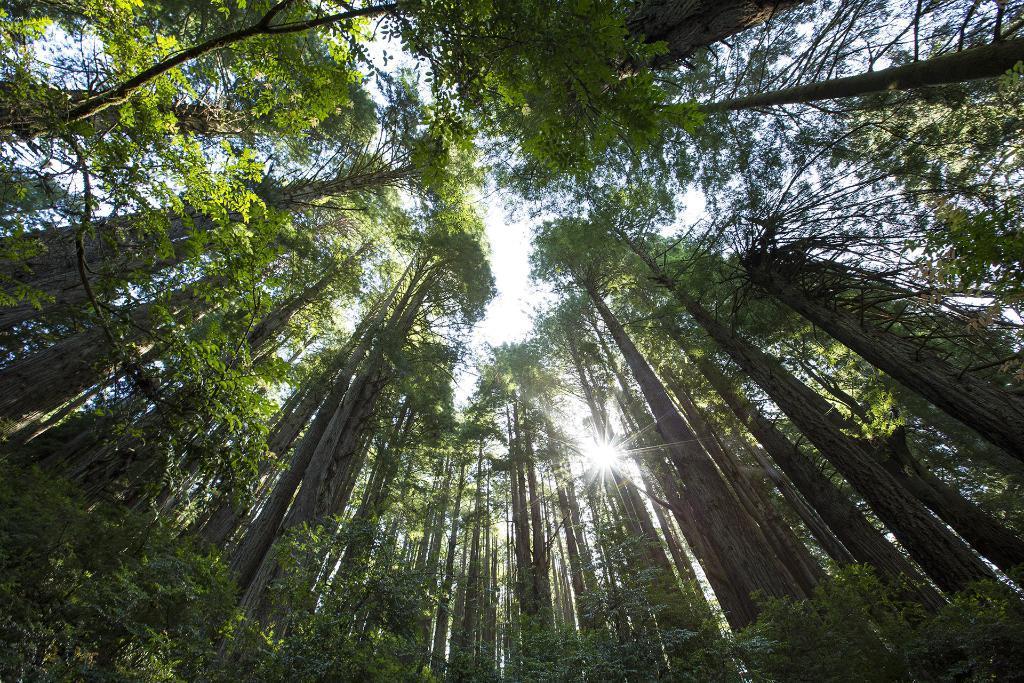Can you describe this image briefly? In this image I can see number of trees and in the background I can see the sky. I can also see the sun in the centre of this image. 